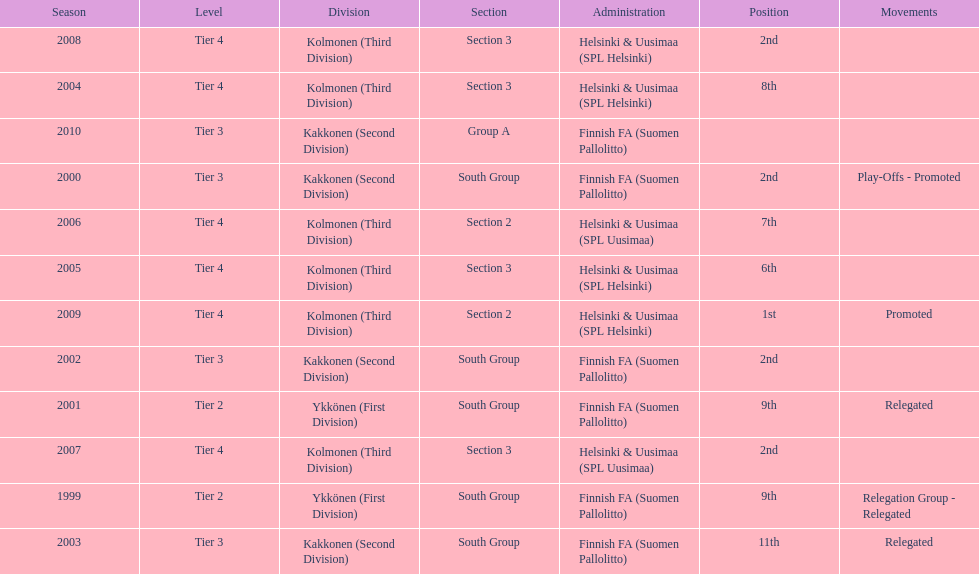What position did this team get after getting 9th place in 1999? 2nd. 